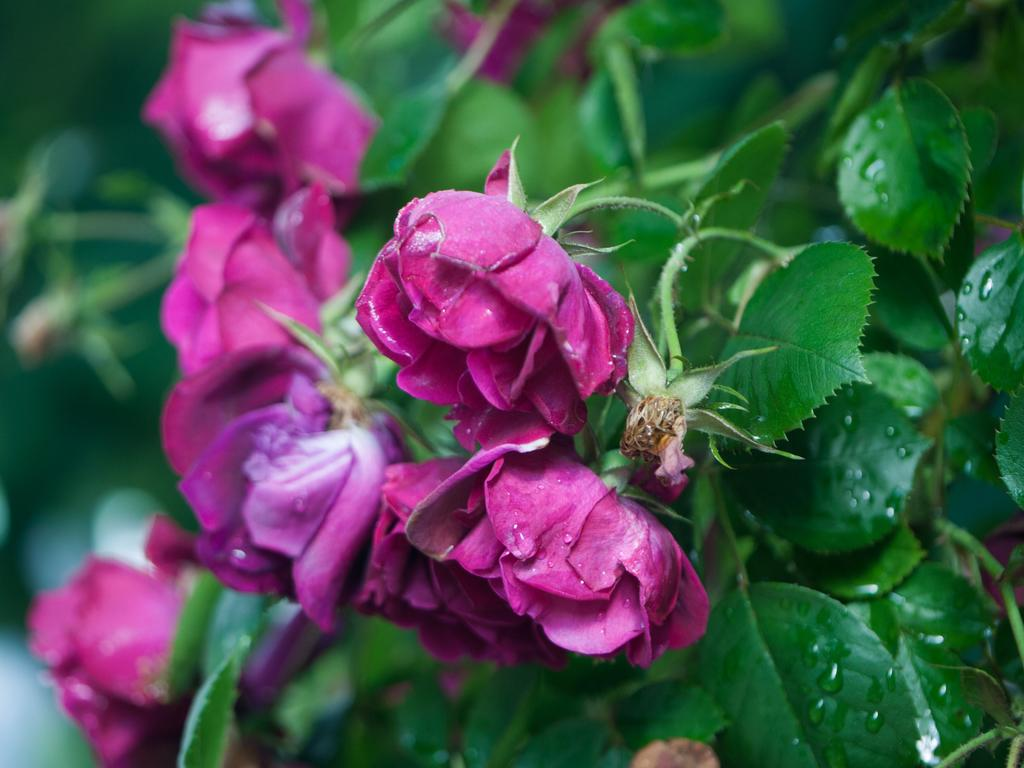What type of plant is visible in the image? There is a rose plant in the image. What can be seen on the rose plant? There are rose flowers and leaves in the image. What type of shoe is visible in the image? There is no shoe present in the image; it features a rose plant with flowers and leaves. What type of lace is used to decorate the tray in the image? There is no tray or lace present in the image; it only contains a rose plant with flowers and leaves. 